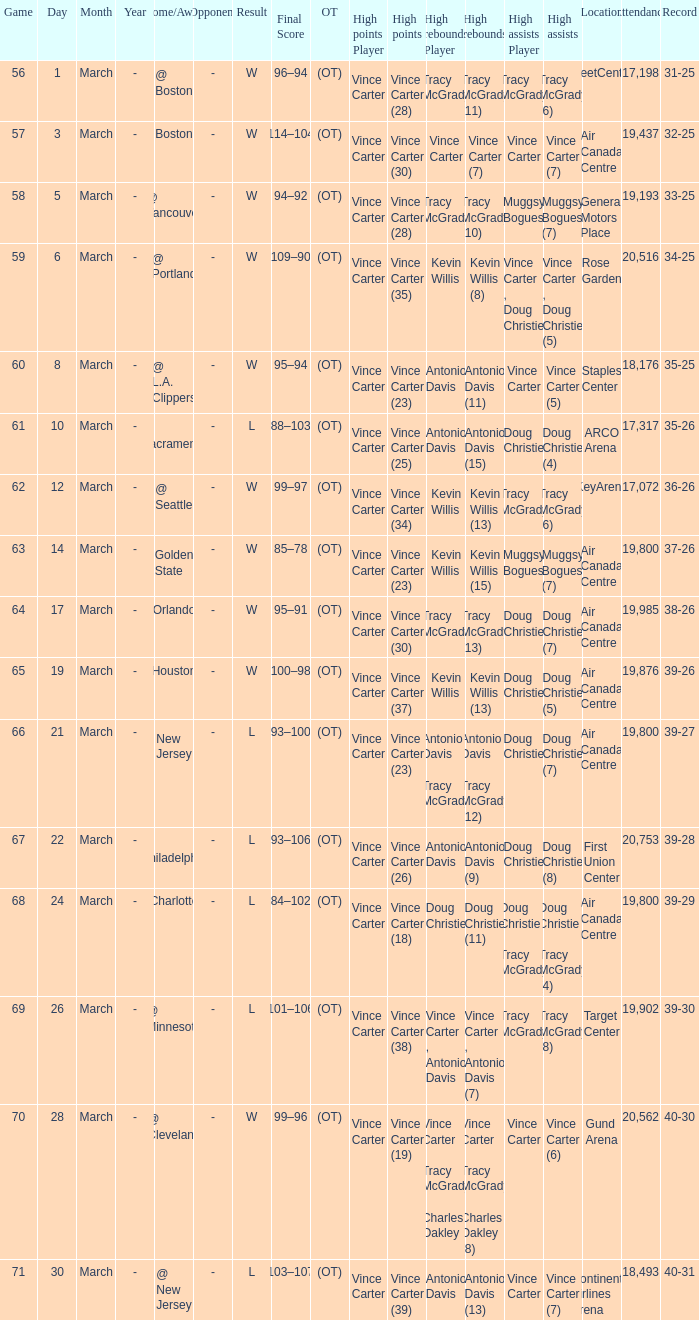Parse the table in full. {'header': ['Game', 'Day', 'Month', 'Year', 'Home/Away', 'Opponent', 'Result', 'Final Score', 'OT', 'High points Player', 'High points', 'High rebounds Player', 'High rebounds', 'High assists Player', 'High assists', 'Location', 'Attendance', 'Record'], 'rows': [['56', '1', 'March', '-', '@ Boston', '-', 'W', '96–94', '(OT)', 'Vince Carter', 'Vince Carter (28)', 'Tracy McGrady', 'Tracy McGrady (11)', 'Tracy McGrady', 'Tracy McGrady (6)', 'FleetCenter', '17,198', '31-25'], ['57', '3', 'March', '-', 'Boston', '-', 'W', '114–104', '(OT)', 'Vince Carter', 'Vince Carter (30)', 'Vince Carter', 'Vince Carter (7)', 'Vince Carter', 'Vince Carter (7)', 'Air Canada Centre', '19,437', '32-25'], ['58', '5', 'March', '-', '@ Vancouver', '-', 'W', '94–92', '(OT)', 'Vince Carter', 'Vince Carter (28)', 'Tracy McGrady', 'Tracy McGrady (10)', 'Muggsy Bogues', 'Muggsy Bogues (7)', 'General Motors Place', '19,193', '33-25'], ['59', '6', 'March', '-', '@ Portland', '-', 'W', '109–90', '(OT)', 'Vince Carter', 'Vince Carter (35)', 'Kevin Willis', 'Kevin Willis (8)', 'Vince Carter , Doug Christie', 'Vince Carter , Doug Christie (5)', 'Rose Garden', '20,516', '34-25'], ['60', '8', 'March', '-', '@ L.A. Clippers', '-', 'W', '95–94', '(OT)', 'Vince Carter', 'Vince Carter (23)', 'Antonio Davis', 'Antonio Davis (11)', 'Vince Carter', 'Vince Carter (5)', 'Staples Center', '18,176', '35-25'], ['61', '10', 'March', '-', '@ Sacramento', '-', 'L', '88–103', '(OT)', 'Vince Carter', 'Vince Carter (25)', 'Antonio Davis', 'Antonio Davis (15)', 'Doug Christie', 'Doug Christie (4)', 'ARCO Arena', '17,317', '35-26'], ['62', '12', 'March', '-', '@ Seattle', '-', 'W', '99–97', '(OT)', 'Vince Carter', 'Vince Carter (34)', 'Kevin Willis', 'Kevin Willis (13)', 'Tracy McGrady', 'Tracy McGrady (6)', 'KeyArena', '17,072', '36-26'], ['63', '14', 'March', '-', 'Golden State', '-', 'W', '85–78', '(OT)', 'Vince Carter', 'Vince Carter (23)', 'Kevin Willis', 'Kevin Willis (15)', 'Muggsy Bogues', 'Muggsy Bogues (7)', 'Air Canada Centre', '19,800', '37-26'], ['64', '17', 'March', '-', 'Orlando', '-', 'W', '95–91', '(OT)', 'Vince Carter', 'Vince Carter (30)', 'Tracy McGrady', 'Tracy McGrady (13)', 'Doug Christie', 'Doug Christie (7)', 'Air Canada Centre', '19,985', '38-26'], ['65', '19', 'March', '-', 'Houston', '-', 'W', '100–98', '(OT)', 'Vince Carter', 'Vince Carter (37)', 'Kevin Willis', 'Kevin Willis (13)', 'Doug Christie', 'Doug Christie (5)', 'Air Canada Centre', '19,876', '39-26'], ['66', '21', 'March', '-', 'New Jersey', '-', 'L', '93–100', '(OT)', 'Vince Carter', 'Vince Carter (23)', 'Antonio Davis , Tracy McGrady', 'Antonio Davis , Tracy McGrady (12)', 'Doug Christie', 'Doug Christie (7)', 'Air Canada Centre', '19,800', '39-27'], ['67', '22', 'March', '-', '@ Philadelphia', '-', 'L', '93–106', '(OT)', 'Vince Carter', 'Vince Carter (26)', 'Antonio Davis', 'Antonio Davis (9)', 'Doug Christie', 'Doug Christie (8)', 'First Union Center', '20,753', '39-28'], ['68', '24', 'March', '-', 'Charlotte', '-', 'L', '84–102', '(OT)', 'Vince Carter', 'Vince Carter (18)', 'Doug Christie', 'Doug Christie (11)', 'Doug Christie , Tracy McGrady', 'Doug Christie , Tracy McGrady (4)', 'Air Canada Centre', '19,800', '39-29'], ['69', '26', 'March', '-', '@ Minnesota', '-', 'L', '101–106', '(OT)', 'Vince Carter', 'Vince Carter (38)', 'Vince Carter , Antonio Davis', 'Vince Carter , Antonio Davis (7)', 'Tracy McGrady', 'Tracy McGrady (8)', 'Target Center', '19,902', '39-30'], ['70', '28', 'March', '-', '@ Cleveland', '-', 'W', '99–96', '(OT)', 'Vince Carter', 'Vince Carter (19)', 'Vince Carter , Tracy McGrady , Charles Oakley', 'Vince Carter , Tracy McGrady , Charles Oakley (8)', 'Vince Carter', 'Vince Carter (6)', 'Gund Arena', '20,562', '40-30'], ['71', '30', 'March', '-', '@ New Jersey', '-', 'L', '103–107', '(OT)', 'Vince Carter', 'Vince Carter (39)', 'Antonio Davis', 'Antonio Davis (13)', 'Vince Carter', 'Vince Carter (7)', 'Continental Airlines Arena', '18,493', '40-31']]} How many people had the high assists @ minnesota? 1.0. 